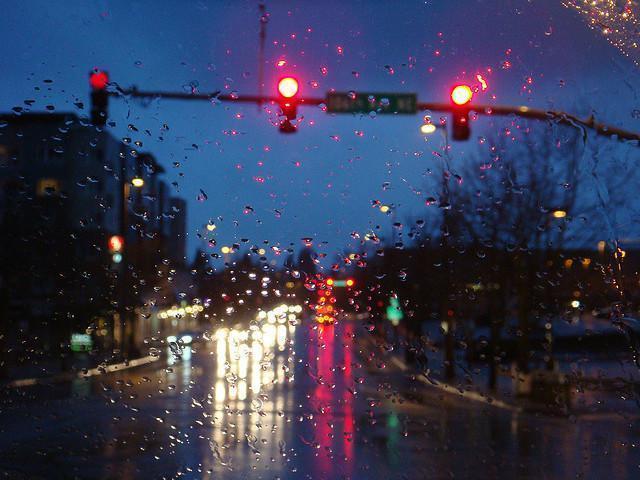What's seen on the window?
Choose the right answer from the provided options to respond to the question.
Options: Insects, fingerprints, raindrops, stickers. Raindrops. 